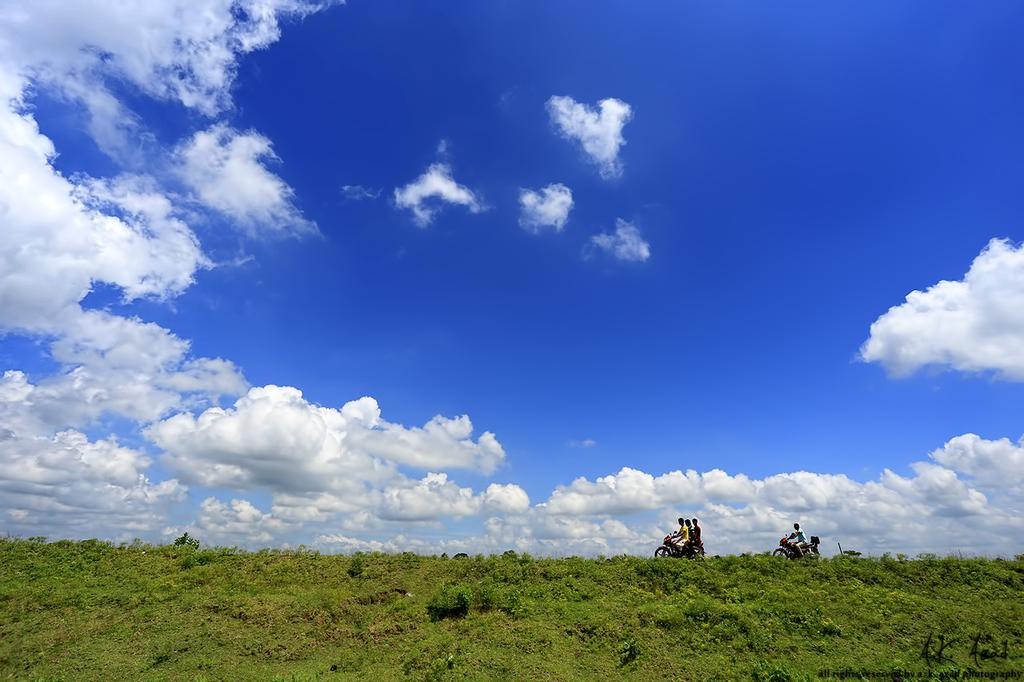How many people are in the image? There are four persons in the image. What are the persons doing in the image? The persons are on a motorcycle. Where is the motorcycle located? The motorcycle is on grassland. What is visible in the background of the image? The sky is visible in the image, and clouds are present in the sky. Can you hear the frog's cry in the image? There is no frog or sound present in the image, so it is not possible to hear a frog's cry. Is there a note left on the motorcycle in the image? There is no mention of a note in the image, so it cannot be determined if one is present. 